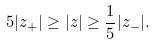Convert formula to latex. <formula><loc_0><loc_0><loc_500><loc_500>5 | z _ { + } | \geq | z | \geq \frac { 1 } { 5 } | z _ { - } | .</formula> 